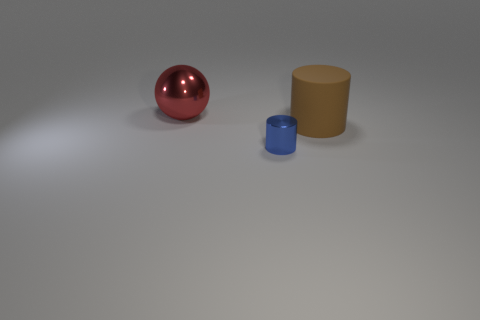Add 2 large blue cylinders. How many objects exist? 5 Subtract all balls. How many objects are left? 2 Subtract all metal cylinders. Subtract all large brown cylinders. How many objects are left? 1 Add 2 large brown things. How many large brown things are left? 3 Add 1 tiny metal things. How many tiny metal things exist? 2 Subtract 0 gray balls. How many objects are left? 3 